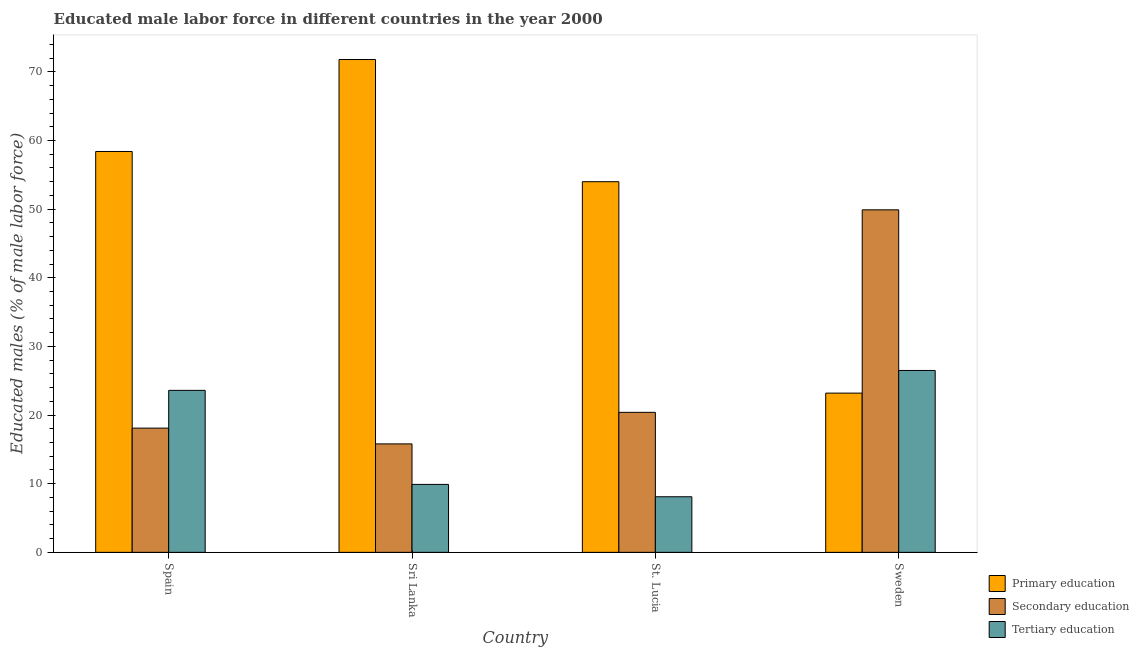How many different coloured bars are there?
Provide a short and direct response. 3. How many groups of bars are there?
Offer a terse response. 4. Are the number of bars per tick equal to the number of legend labels?
Offer a terse response. Yes. How many bars are there on the 2nd tick from the left?
Ensure brevity in your answer.  3. What is the label of the 3rd group of bars from the left?
Offer a terse response. St. Lucia. In how many cases, is the number of bars for a given country not equal to the number of legend labels?
Your answer should be very brief. 0. What is the percentage of male labor force who received primary education in Sweden?
Offer a terse response. 23.2. Across all countries, what is the maximum percentage of male labor force who received primary education?
Offer a terse response. 71.8. Across all countries, what is the minimum percentage of male labor force who received secondary education?
Keep it short and to the point. 15.8. In which country was the percentage of male labor force who received primary education minimum?
Offer a terse response. Sweden. What is the total percentage of male labor force who received primary education in the graph?
Offer a very short reply. 207.4. What is the difference between the percentage of male labor force who received tertiary education in Spain and that in Sweden?
Ensure brevity in your answer.  -2.9. What is the difference between the percentage of male labor force who received primary education in Spain and the percentage of male labor force who received secondary education in St. Lucia?
Provide a succinct answer. 38. What is the average percentage of male labor force who received primary education per country?
Make the answer very short. 51.85. What is the difference between the percentage of male labor force who received tertiary education and percentage of male labor force who received primary education in Spain?
Your answer should be very brief. -34.8. What is the ratio of the percentage of male labor force who received secondary education in Spain to that in Sri Lanka?
Your answer should be very brief. 1.15. Is the difference between the percentage of male labor force who received secondary education in Spain and St. Lucia greater than the difference between the percentage of male labor force who received tertiary education in Spain and St. Lucia?
Keep it short and to the point. No. What is the difference between the highest and the second highest percentage of male labor force who received tertiary education?
Make the answer very short. 2.9. What is the difference between the highest and the lowest percentage of male labor force who received tertiary education?
Make the answer very short. 18.4. In how many countries, is the percentage of male labor force who received tertiary education greater than the average percentage of male labor force who received tertiary education taken over all countries?
Ensure brevity in your answer.  2. What does the 1st bar from the right in St. Lucia represents?
Provide a short and direct response. Tertiary education. How many bars are there?
Ensure brevity in your answer.  12. Are all the bars in the graph horizontal?
Offer a terse response. No. Where does the legend appear in the graph?
Keep it short and to the point. Bottom right. How are the legend labels stacked?
Offer a terse response. Vertical. What is the title of the graph?
Offer a terse response. Educated male labor force in different countries in the year 2000. Does "Social Protection" appear as one of the legend labels in the graph?
Provide a short and direct response. No. What is the label or title of the Y-axis?
Keep it short and to the point. Educated males (% of male labor force). What is the Educated males (% of male labor force) in Primary education in Spain?
Offer a terse response. 58.4. What is the Educated males (% of male labor force) in Secondary education in Spain?
Your answer should be very brief. 18.1. What is the Educated males (% of male labor force) in Tertiary education in Spain?
Offer a terse response. 23.6. What is the Educated males (% of male labor force) in Primary education in Sri Lanka?
Your answer should be compact. 71.8. What is the Educated males (% of male labor force) in Secondary education in Sri Lanka?
Provide a short and direct response. 15.8. What is the Educated males (% of male labor force) in Tertiary education in Sri Lanka?
Provide a succinct answer. 9.9. What is the Educated males (% of male labor force) in Primary education in St. Lucia?
Make the answer very short. 54. What is the Educated males (% of male labor force) of Secondary education in St. Lucia?
Your response must be concise. 20.4. What is the Educated males (% of male labor force) in Tertiary education in St. Lucia?
Keep it short and to the point. 8.1. What is the Educated males (% of male labor force) in Primary education in Sweden?
Make the answer very short. 23.2. What is the Educated males (% of male labor force) of Secondary education in Sweden?
Offer a very short reply. 49.9. Across all countries, what is the maximum Educated males (% of male labor force) in Primary education?
Provide a succinct answer. 71.8. Across all countries, what is the maximum Educated males (% of male labor force) in Secondary education?
Ensure brevity in your answer.  49.9. Across all countries, what is the maximum Educated males (% of male labor force) of Tertiary education?
Offer a terse response. 26.5. Across all countries, what is the minimum Educated males (% of male labor force) of Primary education?
Make the answer very short. 23.2. Across all countries, what is the minimum Educated males (% of male labor force) in Secondary education?
Offer a terse response. 15.8. Across all countries, what is the minimum Educated males (% of male labor force) in Tertiary education?
Ensure brevity in your answer.  8.1. What is the total Educated males (% of male labor force) of Primary education in the graph?
Keep it short and to the point. 207.4. What is the total Educated males (% of male labor force) of Secondary education in the graph?
Ensure brevity in your answer.  104.2. What is the total Educated males (% of male labor force) in Tertiary education in the graph?
Your answer should be compact. 68.1. What is the difference between the Educated males (% of male labor force) in Secondary education in Spain and that in Sri Lanka?
Your answer should be very brief. 2.3. What is the difference between the Educated males (% of male labor force) of Tertiary education in Spain and that in Sri Lanka?
Offer a very short reply. 13.7. What is the difference between the Educated males (% of male labor force) of Primary education in Spain and that in Sweden?
Provide a short and direct response. 35.2. What is the difference between the Educated males (% of male labor force) of Secondary education in Spain and that in Sweden?
Make the answer very short. -31.8. What is the difference between the Educated males (% of male labor force) of Tertiary education in Spain and that in Sweden?
Offer a very short reply. -2.9. What is the difference between the Educated males (% of male labor force) of Primary education in Sri Lanka and that in St. Lucia?
Ensure brevity in your answer.  17.8. What is the difference between the Educated males (% of male labor force) in Tertiary education in Sri Lanka and that in St. Lucia?
Provide a short and direct response. 1.8. What is the difference between the Educated males (% of male labor force) in Primary education in Sri Lanka and that in Sweden?
Offer a terse response. 48.6. What is the difference between the Educated males (% of male labor force) in Secondary education in Sri Lanka and that in Sweden?
Give a very brief answer. -34.1. What is the difference between the Educated males (% of male labor force) in Tertiary education in Sri Lanka and that in Sweden?
Offer a terse response. -16.6. What is the difference between the Educated males (% of male labor force) of Primary education in St. Lucia and that in Sweden?
Keep it short and to the point. 30.8. What is the difference between the Educated males (% of male labor force) in Secondary education in St. Lucia and that in Sweden?
Make the answer very short. -29.5. What is the difference between the Educated males (% of male labor force) of Tertiary education in St. Lucia and that in Sweden?
Provide a short and direct response. -18.4. What is the difference between the Educated males (% of male labor force) of Primary education in Spain and the Educated males (% of male labor force) of Secondary education in Sri Lanka?
Make the answer very short. 42.6. What is the difference between the Educated males (% of male labor force) in Primary education in Spain and the Educated males (% of male labor force) in Tertiary education in Sri Lanka?
Your answer should be very brief. 48.5. What is the difference between the Educated males (% of male labor force) of Primary education in Spain and the Educated males (% of male labor force) of Secondary education in St. Lucia?
Your answer should be very brief. 38. What is the difference between the Educated males (% of male labor force) in Primary education in Spain and the Educated males (% of male labor force) in Tertiary education in St. Lucia?
Provide a short and direct response. 50.3. What is the difference between the Educated males (% of male labor force) in Primary education in Spain and the Educated males (% of male labor force) in Secondary education in Sweden?
Provide a succinct answer. 8.5. What is the difference between the Educated males (% of male labor force) in Primary education in Spain and the Educated males (% of male labor force) in Tertiary education in Sweden?
Your response must be concise. 31.9. What is the difference between the Educated males (% of male labor force) of Primary education in Sri Lanka and the Educated males (% of male labor force) of Secondary education in St. Lucia?
Give a very brief answer. 51.4. What is the difference between the Educated males (% of male labor force) in Primary education in Sri Lanka and the Educated males (% of male labor force) in Tertiary education in St. Lucia?
Make the answer very short. 63.7. What is the difference between the Educated males (% of male labor force) of Primary education in Sri Lanka and the Educated males (% of male labor force) of Secondary education in Sweden?
Keep it short and to the point. 21.9. What is the difference between the Educated males (% of male labor force) of Primary education in Sri Lanka and the Educated males (% of male labor force) of Tertiary education in Sweden?
Give a very brief answer. 45.3. What is the difference between the Educated males (% of male labor force) in Primary education in St. Lucia and the Educated males (% of male labor force) in Tertiary education in Sweden?
Provide a short and direct response. 27.5. What is the average Educated males (% of male labor force) of Primary education per country?
Your response must be concise. 51.85. What is the average Educated males (% of male labor force) in Secondary education per country?
Ensure brevity in your answer.  26.05. What is the average Educated males (% of male labor force) of Tertiary education per country?
Your response must be concise. 17.02. What is the difference between the Educated males (% of male labor force) of Primary education and Educated males (% of male labor force) of Secondary education in Spain?
Provide a short and direct response. 40.3. What is the difference between the Educated males (% of male labor force) in Primary education and Educated males (% of male labor force) in Tertiary education in Spain?
Make the answer very short. 34.8. What is the difference between the Educated males (% of male labor force) in Primary education and Educated males (% of male labor force) in Tertiary education in Sri Lanka?
Your response must be concise. 61.9. What is the difference between the Educated males (% of male labor force) of Secondary education and Educated males (% of male labor force) of Tertiary education in Sri Lanka?
Ensure brevity in your answer.  5.9. What is the difference between the Educated males (% of male labor force) of Primary education and Educated males (% of male labor force) of Secondary education in St. Lucia?
Keep it short and to the point. 33.6. What is the difference between the Educated males (% of male labor force) of Primary education and Educated males (% of male labor force) of Tertiary education in St. Lucia?
Give a very brief answer. 45.9. What is the difference between the Educated males (% of male labor force) of Primary education and Educated males (% of male labor force) of Secondary education in Sweden?
Make the answer very short. -26.7. What is the difference between the Educated males (% of male labor force) of Primary education and Educated males (% of male labor force) of Tertiary education in Sweden?
Offer a terse response. -3.3. What is the difference between the Educated males (% of male labor force) in Secondary education and Educated males (% of male labor force) in Tertiary education in Sweden?
Provide a short and direct response. 23.4. What is the ratio of the Educated males (% of male labor force) in Primary education in Spain to that in Sri Lanka?
Ensure brevity in your answer.  0.81. What is the ratio of the Educated males (% of male labor force) in Secondary education in Spain to that in Sri Lanka?
Keep it short and to the point. 1.15. What is the ratio of the Educated males (% of male labor force) of Tertiary education in Spain to that in Sri Lanka?
Your answer should be compact. 2.38. What is the ratio of the Educated males (% of male labor force) of Primary education in Spain to that in St. Lucia?
Keep it short and to the point. 1.08. What is the ratio of the Educated males (% of male labor force) of Secondary education in Spain to that in St. Lucia?
Offer a very short reply. 0.89. What is the ratio of the Educated males (% of male labor force) in Tertiary education in Spain to that in St. Lucia?
Ensure brevity in your answer.  2.91. What is the ratio of the Educated males (% of male labor force) of Primary education in Spain to that in Sweden?
Your answer should be compact. 2.52. What is the ratio of the Educated males (% of male labor force) of Secondary education in Spain to that in Sweden?
Ensure brevity in your answer.  0.36. What is the ratio of the Educated males (% of male labor force) in Tertiary education in Spain to that in Sweden?
Ensure brevity in your answer.  0.89. What is the ratio of the Educated males (% of male labor force) in Primary education in Sri Lanka to that in St. Lucia?
Offer a very short reply. 1.33. What is the ratio of the Educated males (% of male labor force) in Secondary education in Sri Lanka to that in St. Lucia?
Provide a succinct answer. 0.77. What is the ratio of the Educated males (% of male labor force) of Tertiary education in Sri Lanka to that in St. Lucia?
Provide a succinct answer. 1.22. What is the ratio of the Educated males (% of male labor force) of Primary education in Sri Lanka to that in Sweden?
Your response must be concise. 3.09. What is the ratio of the Educated males (% of male labor force) of Secondary education in Sri Lanka to that in Sweden?
Give a very brief answer. 0.32. What is the ratio of the Educated males (% of male labor force) in Tertiary education in Sri Lanka to that in Sweden?
Provide a succinct answer. 0.37. What is the ratio of the Educated males (% of male labor force) in Primary education in St. Lucia to that in Sweden?
Ensure brevity in your answer.  2.33. What is the ratio of the Educated males (% of male labor force) of Secondary education in St. Lucia to that in Sweden?
Provide a short and direct response. 0.41. What is the ratio of the Educated males (% of male labor force) in Tertiary education in St. Lucia to that in Sweden?
Provide a succinct answer. 0.31. What is the difference between the highest and the second highest Educated males (% of male labor force) of Primary education?
Keep it short and to the point. 13.4. What is the difference between the highest and the second highest Educated males (% of male labor force) of Secondary education?
Your answer should be compact. 29.5. What is the difference between the highest and the second highest Educated males (% of male labor force) in Tertiary education?
Provide a succinct answer. 2.9. What is the difference between the highest and the lowest Educated males (% of male labor force) of Primary education?
Your response must be concise. 48.6. What is the difference between the highest and the lowest Educated males (% of male labor force) in Secondary education?
Keep it short and to the point. 34.1. 